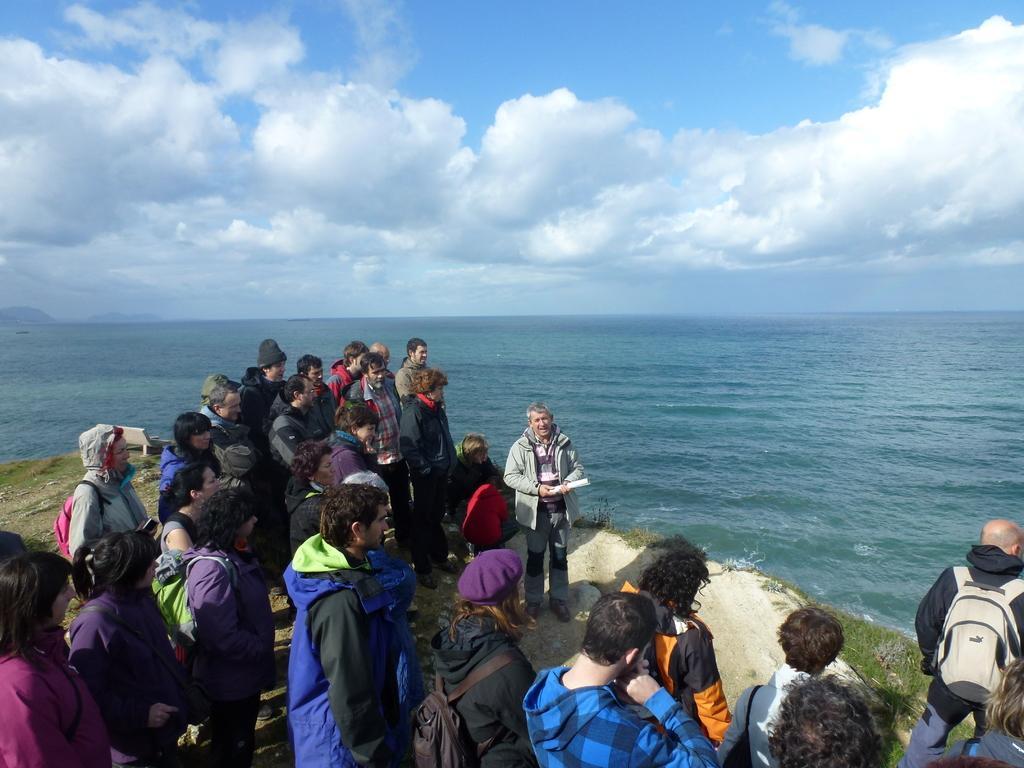Describe this image in one or two sentences. In this image there are a few people standing on the shore of the sea, in the background of the image there is water. 